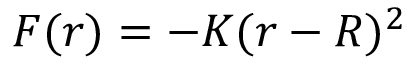Convert formula to latex. <formula><loc_0><loc_0><loc_500><loc_500>F ( r ) = - K ( r - R ) ^ { 2 }</formula> 